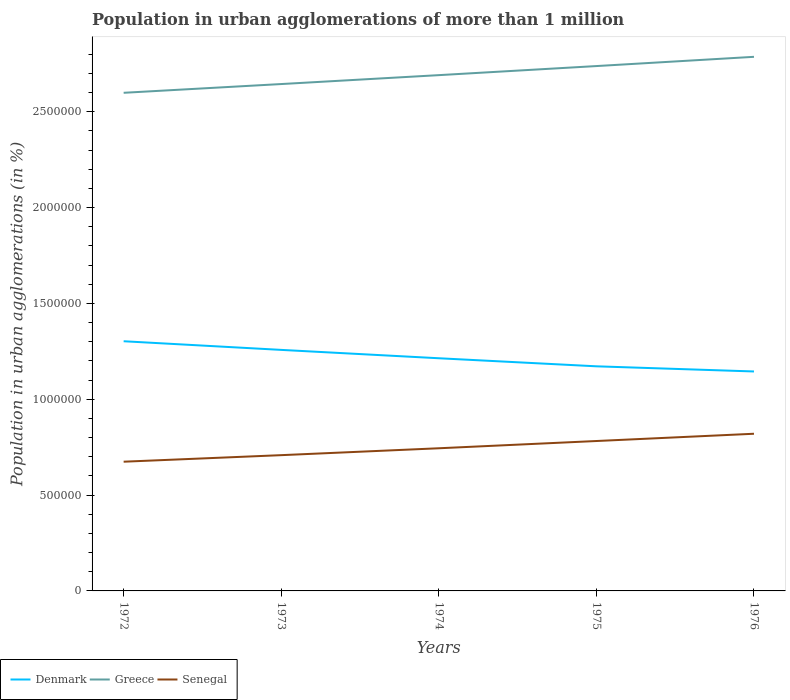How many different coloured lines are there?
Offer a very short reply. 3. Across all years, what is the maximum population in urban agglomerations in Denmark?
Your response must be concise. 1.14e+06. In which year was the population in urban agglomerations in Greece maximum?
Provide a succinct answer. 1972. What is the total population in urban agglomerations in Senegal in the graph?
Offer a terse response. -7.37e+04. What is the difference between the highest and the second highest population in urban agglomerations in Denmark?
Provide a succinct answer. 1.58e+05. Is the population in urban agglomerations in Senegal strictly greater than the population in urban agglomerations in Denmark over the years?
Keep it short and to the point. Yes. How many lines are there?
Keep it short and to the point. 3. How many years are there in the graph?
Your answer should be compact. 5. What is the difference between two consecutive major ticks on the Y-axis?
Give a very brief answer. 5.00e+05. Does the graph contain grids?
Your answer should be compact. No. Where does the legend appear in the graph?
Offer a terse response. Bottom left. How are the legend labels stacked?
Provide a succinct answer. Horizontal. What is the title of the graph?
Your answer should be compact. Population in urban agglomerations of more than 1 million. Does "Uganda" appear as one of the legend labels in the graph?
Ensure brevity in your answer.  No. What is the label or title of the X-axis?
Keep it short and to the point. Years. What is the label or title of the Y-axis?
Give a very brief answer. Population in urban agglomerations (in %). What is the Population in urban agglomerations (in %) in Denmark in 1972?
Your response must be concise. 1.30e+06. What is the Population in urban agglomerations (in %) in Greece in 1972?
Ensure brevity in your answer.  2.60e+06. What is the Population in urban agglomerations (in %) in Senegal in 1972?
Provide a succinct answer. 6.74e+05. What is the Population in urban agglomerations (in %) in Denmark in 1973?
Your response must be concise. 1.26e+06. What is the Population in urban agglomerations (in %) of Greece in 1973?
Give a very brief answer. 2.64e+06. What is the Population in urban agglomerations (in %) of Senegal in 1973?
Provide a succinct answer. 7.08e+05. What is the Population in urban agglomerations (in %) of Denmark in 1974?
Provide a short and direct response. 1.21e+06. What is the Population in urban agglomerations (in %) of Greece in 1974?
Offer a terse response. 2.69e+06. What is the Population in urban agglomerations (in %) in Senegal in 1974?
Offer a terse response. 7.44e+05. What is the Population in urban agglomerations (in %) of Denmark in 1975?
Provide a short and direct response. 1.17e+06. What is the Population in urban agglomerations (in %) of Greece in 1975?
Provide a short and direct response. 2.74e+06. What is the Population in urban agglomerations (in %) in Senegal in 1975?
Offer a terse response. 7.82e+05. What is the Population in urban agglomerations (in %) in Denmark in 1976?
Ensure brevity in your answer.  1.14e+06. What is the Population in urban agglomerations (in %) in Greece in 1976?
Your answer should be compact. 2.79e+06. What is the Population in urban agglomerations (in %) in Senegal in 1976?
Provide a succinct answer. 8.20e+05. Across all years, what is the maximum Population in urban agglomerations (in %) in Denmark?
Provide a succinct answer. 1.30e+06. Across all years, what is the maximum Population in urban agglomerations (in %) in Greece?
Your answer should be very brief. 2.79e+06. Across all years, what is the maximum Population in urban agglomerations (in %) in Senegal?
Provide a short and direct response. 8.20e+05. Across all years, what is the minimum Population in urban agglomerations (in %) of Denmark?
Your answer should be very brief. 1.14e+06. Across all years, what is the minimum Population in urban agglomerations (in %) of Greece?
Provide a succinct answer. 2.60e+06. Across all years, what is the minimum Population in urban agglomerations (in %) in Senegal?
Offer a terse response. 6.74e+05. What is the total Population in urban agglomerations (in %) of Denmark in the graph?
Offer a terse response. 6.09e+06. What is the total Population in urban agglomerations (in %) of Greece in the graph?
Offer a very short reply. 1.35e+07. What is the total Population in urban agglomerations (in %) in Senegal in the graph?
Ensure brevity in your answer.  3.73e+06. What is the difference between the Population in urban agglomerations (in %) of Denmark in 1972 and that in 1973?
Make the answer very short. 4.51e+04. What is the difference between the Population in urban agglomerations (in %) in Greece in 1972 and that in 1973?
Your answer should be very brief. -4.56e+04. What is the difference between the Population in urban agglomerations (in %) in Senegal in 1972 and that in 1973?
Offer a terse response. -3.42e+04. What is the difference between the Population in urban agglomerations (in %) in Denmark in 1972 and that in 1974?
Keep it short and to the point. 8.87e+04. What is the difference between the Population in urban agglomerations (in %) of Greece in 1972 and that in 1974?
Offer a terse response. -9.22e+04. What is the difference between the Population in urban agglomerations (in %) of Senegal in 1972 and that in 1974?
Your answer should be compact. -7.01e+04. What is the difference between the Population in urban agglomerations (in %) in Denmark in 1972 and that in 1975?
Provide a short and direct response. 1.31e+05. What is the difference between the Population in urban agglomerations (in %) in Greece in 1972 and that in 1975?
Your answer should be very brief. -1.39e+05. What is the difference between the Population in urban agglomerations (in %) of Senegal in 1972 and that in 1975?
Ensure brevity in your answer.  -1.08e+05. What is the difference between the Population in urban agglomerations (in %) of Denmark in 1972 and that in 1976?
Your answer should be very brief. 1.58e+05. What is the difference between the Population in urban agglomerations (in %) of Greece in 1972 and that in 1976?
Give a very brief answer. -1.88e+05. What is the difference between the Population in urban agglomerations (in %) in Senegal in 1972 and that in 1976?
Provide a short and direct response. -1.46e+05. What is the difference between the Population in urban agglomerations (in %) in Denmark in 1973 and that in 1974?
Offer a terse response. 4.36e+04. What is the difference between the Population in urban agglomerations (in %) in Greece in 1973 and that in 1974?
Make the answer very short. -4.65e+04. What is the difference between the Population in urban agglomerations (in %) of Senegal in 1973 and that in 1974?
Give a very brief answer. -3.59e+04. What is the difference between the Population in urban agglomerations (in %) of Denmark in 1973 and that in 1975?
Provide a succinct answer. 8.57e+04. What is the difference between the Population in urban agglomerations (in %) in Greece in 1973 and that in 1975?
Provide a short and direct response. -9.38e+04. What is the difference between the Population in urban agglomerations (in %) in Senegal in 1973 and that in 1975?
Provide a short and direct response. -7.37e+04. What is the difference between the Population in urban agglomerations (in %) in Denmark in 1973 and that in 1976?
Give a very brief answer. 1.13e+05. What is the difference between the Population in urban agglomerations (in %) of Greece in 1973 and that in 1976?
Give a very brief answer. -1.42e+05. What is the difference between the Population in urban agglomerations (in %) of Senegal in 1973 and that in 1976?
Make the answer very short. -1.12e+05. What is the difference between the Population in urban agglomerations (in %) in Denmark in 1974 and that in 1975?
Your response must be concise. 4.21e+04. What is the difference between the Population in urban agglomerations (in %) in Greece in 1974 and that in 1975?
Provide a succinct answer. -4.73e+04. What is the difference between the Population in urban agglomerations (in %) of Senegal in 1974 and that in 1975?
Provide a succinct answer. -3.78e+04. What is the difference between the Population in urban agglomerations (in %) of Denmark in 1974 and that in 1976?
Provide a short and direct response. 6.90e+04. What is the difference between the Population in urban agglomerations (in %) in Greece in 1974 and that in 1976?
Your answer should be very brief. -9.56e+04. What is the difference between the Population in urban agglomerations (in %) of Senegal in 1974 and that in 1976?
Your response must be concise. -7.57e+04. What is the difference between the Population in urban agglomerations (in %) of Denmark in 1975 and that in 1976?
Provide a succinct answer. 2.69e+04. What is the difference between the Population in urban agglomerations (in %) in Greece in 1975 and that in 1976?
Provide a short and direct response. -4.82e+04. What is the difference between the Population in urban agglomerations (in %) of Senegal in 1975 and that in 1976?
Offer a terse response. -3.79e+04. What is the difference between the Population in urban agglomerations (in %) in Denmark in 1972 and the Population in urban agglomerations (in %) in Greece in 1973?
Your response must be concise. -1.34e+06. What is the difference between the Population in urban agglomerations (in %) in Denmark in 1972 and the Population in urban agglomerations (in %) in Senegal in 1973?
Your response must be concise. 5.94e+05. What is the difference between the Population in urban agglomerations (in %) in Greece in 1972 and the Population in urban agglomerations (in %) in Senegal in 1973?
Provide a succinct answer. 1.89e+06. What is the difference between the Population in urban agglomerations (in %) of Denmark in 1972 and the Population in urban agglomerations (in %) of Greece in 1974?
Your answer should be very brief. -1.39e+06. What is the difference between the Population in urban agglomerations (in %) of Denmark in 1972 and the Population in urban agglomerations (in %) of Senegal in 1974?
Make the answer very short. 5.58e+05. What is the difference between the Population in urban agglomerations (in %) of Greece in 1972 and the Population in urban agglomerations (in %) of Senegal in 1974?
Ensure brevity in your answer.  1.85e+06. What is the difference between the Population in urban agglomerations (in %) of Denmark in 1972 and the Population in urban agglomerations (in %) of Greece in 1975?
Your response must be concise. -1.44e+06. What is the difference between the Population in urban agglomerations (in %) in Denmark in 1972 and the Population in urban agglomerations (in %) in Senegal in 1975?
Offer a terse response. 5.20e+05. What is the difference between the Population in urban agglomerations (in %) in Greece in 1972 and the Population in urban agglomerations (in %) in Senegal in 1975?
Offer a very short reply. 1.82e+06. What is the difference between the Population in urban agglomerations (in %) of Denmark in 1972 and the Population in urban agglomerations (in %) of Greece in 1976?
Your answer should be compact. -1.48e+06. What is the difference between the Population in urban agglomerations (in %) in Denmark in 1972 and the Population in urban agglomerations (in %) in Senegal in 1976?
Your answer should be compact. 4.83e+05. What is the difference between the Population in urban agglomerations (in %) of Greece in 1972 and the Population in urban agglomerations (in %) of Senegal in 1976?
Your answer should be very brief. 1.78e+06. What is the difference between the Population in urban agglomerations (in %) of Denmark in 1973 and the Population in urban agglomerations (in %) of Greece in 1974?
Offer a terse response. -1.43e+06. What is the difference between the Population in urban agglomerations (in %) of Denmark in 1973 and the Population in urban agglomerations (in %) of Senegal in 1974?
Give a very brief answer. 5.13e+05. What is the difference between the Population in urban agglomerations (in %) in Greece in 1973 and the Population in urban agglomerations (in %) in Senegal in 1974?
Offer a terse response. 1.90e+06. What is the difference between the Population in urban agglomerations (in %) of Denmark in 1973 and the Population in urban agglomerations (in %) of Greece in 1975?
Your answer should be very brief. -1.48e+06. What is the difference between the Population in urban agglomerations (in %) of Denmark in 1973 and the Population in urban agglomerations (in %) of Senegal in 1975?
Make the answer very short. 4.75e+05. What is the difference between the Population in urban agglomerations (in %) in Greece in 1973 and the Population in urban agglomerations (in %) in Senegal in 1975?
Give a very brief answer. 1.86e+06. What is the difference between the Population in urban agglomerations (in %) of Denmark in 1973 and the Population in urban agglomerations (in %) of Greece in 1976?
Provide a short and direct response. -1.53e+06. What is the difference between the Population in urban agglomerations (in %) of Denmark in 1973 and the Population in urban agglomerations (in %) of Senegal in 1976?
Keep it short and to the point. 4.37e+05. What is the difference between the Population in urban agglomerations (in %) of Greece in 1973 and the Population in urban agglomerations (in %) of Senegal in 1976?
Give a very brief answer. 1.82e+06. What is the difference between the Population in urban agglomerations (in %) of Denmark in 1974 and the Population in urban agglomerations (in %) of Greece in 1975?
Make the answer very short. -1.52e+06. What is the difference between the Population in urban agglomerations (in %) of Denmark in 1974 and the Population in urban agglomerations (in %) of Senegal in 1975?
Give a very brief answer. 4.32e+05. What is the difference between the Population in urban agglomerations (in %) of Greece in 1974 and the Population in urban agglomerations (in %) of Senegal in 1975?
Your answer should be very brief. 1.91e+06. What is the difference between the Population in urban agglomerations (in %) in Denmark in 1974 and the Population in urban agglomerations (in %) in Greece in 1976?
Provide a succinct answer. -1.57e+06. What is the difference between the Population in urban agglomerations (in %) of Denmark in 1974 and the Population in urban agglomerations (in %) of Senegal in 1976?
Your answer should be very brief. 3.94e+05. What is the difference between the Population in urban agglomerations (in %) of Greece in 1974 and the Population in urban agglomerations (in %) of Senegal in 1976?
Your answer should be compact. 1.87e+06. What is the difference between the Population in urban agglomerations (in %) of Denmark in 1975 and the Population in urban agglomerations (in %) of Greece in 1976?
Provide a short and direct response. -1.61e+06. What is the difference between the Population in urban agglomerations (in %) in Denmark in 1975 and the Population in urban agglomerations (in %) in Senegal in 1976?
Keep it short and to the point. 3.52e+05. What is the difference between the Population in urban agglomerations (in %) in Greece in 1975 and the Population in urban agglomerations (in %) in Senegal in 1976?
Provide a short and direct response. 1.92e+06. What is the average Population in urban agglomerations (in %) of Denmark per year?
Provide a succinct answer. 1.22e+06. What is the average Population in urban agglomerations (in %) of Greece per year?
Offer a very short reply. 2.69e+06. What is the average Population in urban agglomerations (in %) in Senegal per year?
Offer a very short reply. 7.46e+05. In the year 1972, what is the difference between the Population in urban agglomerations (in %) of Denmark and Population in urban agglomerations (in %) of Greece?
Offer a very short reply. -1.30e+06. In the year 1972, what is the difference between the Population in urban agglomerations (in %) of Denmark and Population in urban agglomerations (in %) of Senegal?
Your answer should be very brief. 6.28e+05. In the year 1972, what is the difference between the Population in urban agglomerations (in %) in Greece and Population in urban agglomerations (in %) in Senegal?
Ensure brevity in your answer.  1.92e+06. In the year 1973, what is the difference between the Population in urban agglomerations (in %) of Denmark and Population in urban agglomerations (in %) of Greece?
Your answer should be very brief. -1.39e+06. In the year 1973, what is the difference between the Population in urban agglomerations (in %) of Denmark and Population in urban agglomerations (in %) of Senegal?
Offer a very short reply. 5.49e+05. In the year 1973, what is the difference between the Population in urban agglomerations (in %) in Greece and Population in urban agglomerations (in %) in Senegal?
Your response must be concise. 1.94e+06. In the year 1974, what is the difference between the Population in urban agglomerations (in %) of Denmark and Population in urban agglomerations (in %) of Greece?
Ensure brevity in your answer.  -1.48e+06. In the year 1974, what is the difference between the Population in urban agglomerations (in %) in Denmark and Population in urban agglomerations (in %) in Senegal?
Your response must be concise. 4.70e+05. In the year 1974, what is the difference between the Population in urban agglomerations (in %) of Greece and Population in urban agglomerations (in %) of Senegal?
Ensure brevity in your answer.  1.95e+06. In the year 1975, what is the difference between the Population in urban agglomerations (in %) in Denmark and Population in urban agglomerations (in %) in Greece?
Ensure brevity in your answer.  -1.57e+06. In the year 1975, what is the difference between the Population in urban agglomerations (in %) of Denmark and Population in urban agglomerations (in %) of Senegal?
Offer a very short reply. 3.90e+05. In the year 1975, what is the difference between the Population in urban agglomerations (in %) in Greece and Population in urban agglomerations (in %) in Senegal?
Keep it short and to the point. 1.96e+06. In the year 1976, what is the difference between the Population in urban agglomerations (in %) in Denmark and Population in urban agglomerations (in %) in Greece?
Offer a terse response. -1.64e+06. In the year 1976, what is the difference between the Population in urban agglomerations (in %) in Denmark and Population in urban agglomerations (in %) in Senegal?
Offer a terse response. 3.25e+05. In the year 1976, what is the difference between the Population in urban agglomerations (in %) of Greece and Population in urban agglomerations (in %) of Senegal?
Provide a short and direct response. 1.97e+06. What is the ratio of the Population in urban agglomerations (in %) in Denmark in 1972 to that in 1973?
Offer a very short reply. 1.04. What is the ratio of the Population in urban agglomerations (in %) of Greece in 1972 to that in 1973?
Provide a short and direct response. 0.98. What is the ratio of the Population in urban agglomerations (in %) of Senegal in 1972 to that in 1973?
Your response must be concise. 0.95. What is the ratio of the Population in urban agglomerations (in %) of Denmark in 1972 to that in 1974?
Offer a very short reply. 1.07. What is the ratio of the Population in urban agglomerations (in %) of Greece in 1972 to that in 1974?
Make the answer very short. 0.97. What is the ratio of the Population in urban agglomerations (in %) in Senegal in 1972 to that in 1974?
Offer a very short reply. 0.91. What is the ratio of the Population in urban agglomerations (in %) in Denmark in 1972 to that in 1975?
Your answer should be very brief. 1.11. What is the ratio of the Population in urban agglomerations (in %) in Greece in 1972 to that in 1975?
Provide a succinct answer. 0.95. What is the ratio of the Population in urban agglomerations (in %) of Senegal in 1972 to that in 1975?
Your answer should be very brief. 0.86. What is the ratio of the Population in urban agglomerations (in %) of Denmark in 1972 to that in 1976?
Offer a terse response. 1.14. What is the ratio of the Population in urban agglomerations (in %) of Greece in 1972 to that in 1976?
Your answer should be very brief. 0.93. What is the ratio of the Population in urban agglomerations (in %) of Senegal in 1972 to that in 1976?
Ensure brevity in your answer.  0.82. What is the ratio of the Population in urban agglomerations (in %) in Denmark in 1973 to that in 1974?
Ensure brevity in your answer.  1.04. What is the ratio of the Population in urban agglomerations (in %) in Greece in 1973 to that in 1974?
Ensure brevity in your answer.  0.98. What is the ratio of the Population in urban agglomerations (in %) in Senegal in 1973 to that in 1974?
Provide a succinct answer. 0.95. What is the ratio of the Population in urban agglomerations (in %) in Denmark in 1973 to that in 1975?
Make the answer very short. 1.07. What is the ratio of the Population in urban agglomerations (in %) in Greece in 1973 to that in 1975?
Your response must be concise. 0.97. What is the ratio of the Population in urban agglomerations (in %) of Senegal in 1973 to that in 1975?
Make the answer very short. 0.91. What is the ratio of the Population in urban agglomerations (in %) of Denmark in 1973 to that in 1976?
Make the answer very short. 1.1. What is the ratio of the Population in urban agglomerations (in %) of Greece in 1973 to that in 1976?
Make the answer very short. 0.95. What is the ratio of the Population in urban agglomerations (in %) of Senegal in 1973 to that in 1976?
Offer a very short reply. 0.86. What is the ratio of the Population in urban agglomerations (in %) in Denmark in 1974 to that in 1975?
Offer a very short reply. 1.04. What is the ratio of the Population in urban agglomerations (in %) in Greece in 1974 to that in 1975?
Offer a very short reply. 0.98. What is the ratio of the Population in urban agglomerations (in %) of Senegal in 1974 to that in 1975?
Give a very brief answer. 0.95. What is the ratio of the Population in urban agglomerations (in %) of Denmark in 1974 to that in 1976?
Your answer should be compact. 1.06. What is the ratio of the Population in urban agglomerations (in %) of Greece in 1974 to that in 1976?
Your answer should be very brief. 0.97. What is the ratio of the Population in urban agglomerations (in %) in Senegal in 1974 to that in 1976?
Offer a terse response. 0.91. What is the ratio of the Population in urban agglomerations (in %) of Denmark in 1975 to that in 1976?
Your answer should be compact. 1.02. What is the ratio of the Population in urban agglomerations (in %) in Greece in 1975 to that in 1976?
Keep it short and to the point. 0.98. What is the ratio of the Population in urban agglomerations (in %) in Senegal in 1975 to that in 1976?
Give a very brief answer. 0.95. What is the difference between the highest and the second highest Population in urban agglomerations (in %) of Denmark?
Your answer should be very brief. 4.51e+04. What is the difference between the highest and the second highest Population in urban agglomerations (in %) in Greece?
Ensure brevity in your answer.  4.82e+04. What is the difference between the highest and the second highest Population in urban agglomerations (in %) of Senegal?
Make the answer very short. 3.79e+04. What is the difference between the highest and the lowest Population in urban agglomerations (in %) of Denmark?
Ensure brevity in your answer.  1.58e+05. What is the difference between the highest and the lowest Population in urban agglomerations (in %) in Greece?
Your response must be concise. 1.88e+05. What is the difference between the highest and the lowest Population in urban agglomerations (in %) of Senegal?
Make the answer very short. 1.46e+05. 